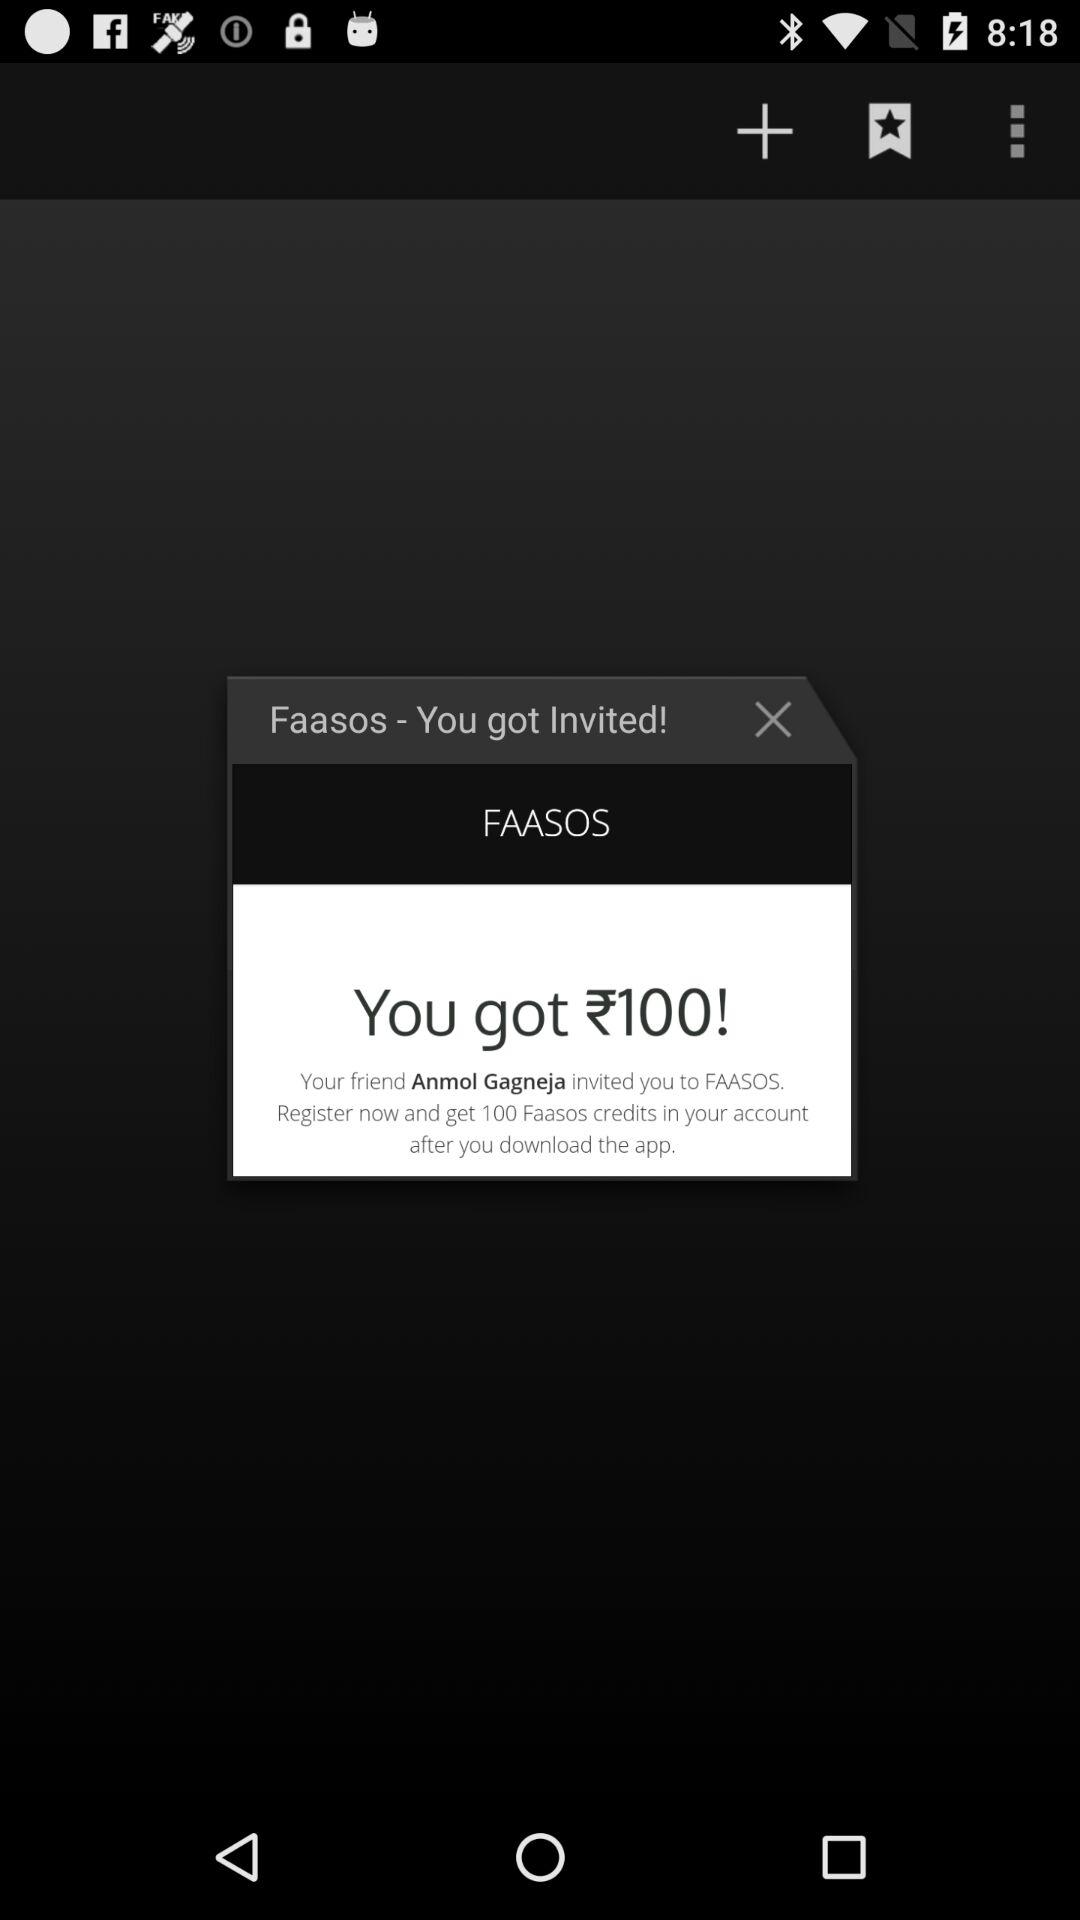How many Faasos credits did Anmol Gagneja invite you to get?
Answer the question using a single word or phrase. 100 